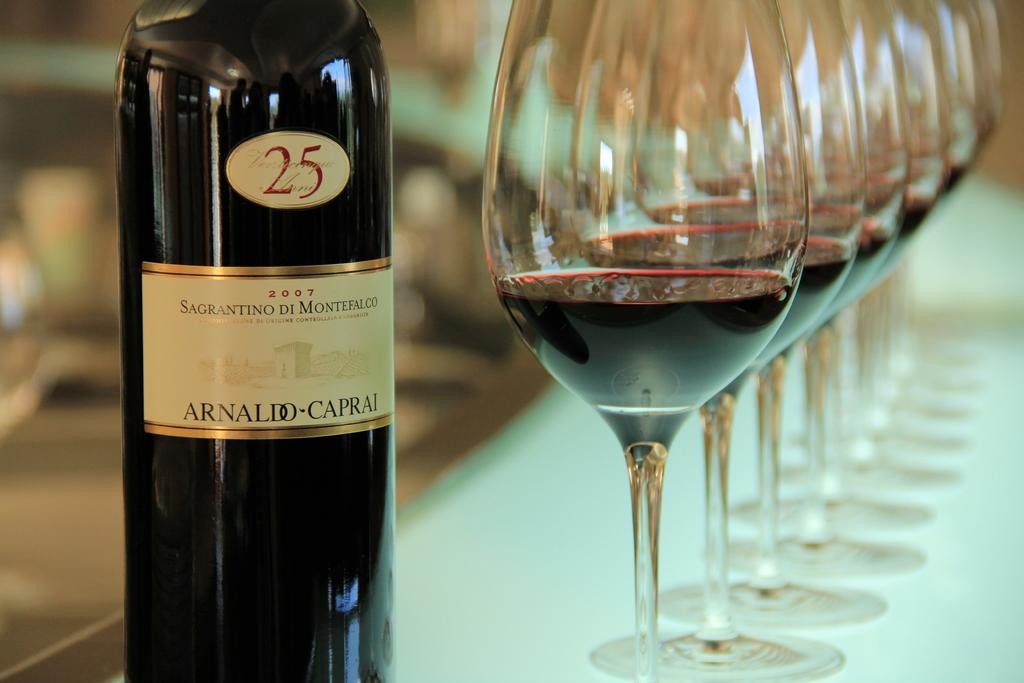What type of table is in the image? There is a white table in the image. What objects are on the table? There are glasses and a bottle on the table. What is unique about the bottle? The bottle has stickers on it. What is inside the glasses? The glasses contain wine. Can you describe the background of the image? The background of the image is blurred. Can you hear the snail talking to the head in the image? There is no snail or head present in the image, so it is not possible to hear them talking. 